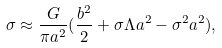Convert formula to latex. <formula><loc_0><loc_0><loc_500><loc_500>\sigma \approx \frac { G } { \pi a ^ { 2 } } ( \frac { b ^ { 2 } } { 2 } + \sigma \Lambda a ^ { 2 } - \sigma ^ { 2 } a ^ { 2 } ) ,</formula> 